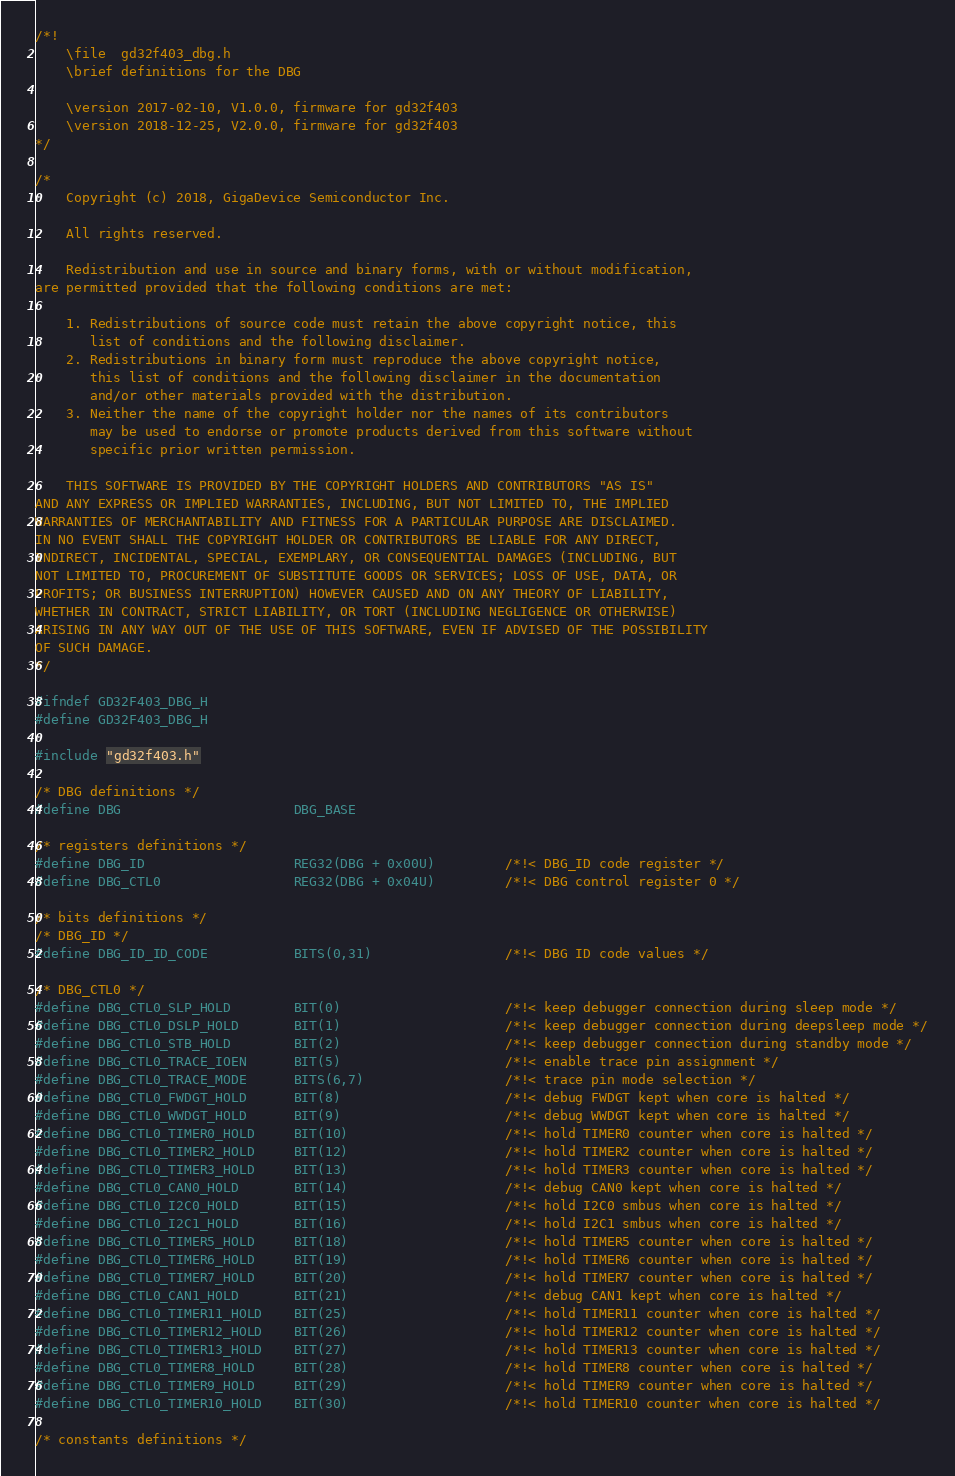<code> <loc_0><loc_0><loc_500><loc_500><_C_>/*!
    \file  gd32f403_dbg.h
    \brief definitions for the DBG

    \version 2017-02-10, V1.0.0, firmware for gd32f403
    \version 2018-12-25, V2.0.0, firmware for gd32f403
*/

/*
    Copyright (c) 2018, GigaDevice Semiconductor Inc.

    All rights reserved.

    Redistribution and use in source and binary forms, with or without modification, 
are permitted provided that the following conditions are met:

    1. Redistributions of source code must retain the above copyright notice, this 
       list of conditions and the following disclaimer.
    2. Redistributions in binary form must reproduce the above copyright notice, 
       this list of conditions and the following disclaimer in the documentation 
       and/or other materials provided with the distribution.
    3. Neither the name of the copyright holder nor the names of its contributors 
       may be used to endorse or promote products derived from this software without 
       specific prior written permission.

    THIS SOFTWARE IS PROVIDED BY THE COPYRIGHT HOLDERS AND CONTRIBUTORS "AS IS" 
AND ANY EXPRESS OR IMPLIED WARRANTIES, INCLUDING, BUT NOT LIMITED TO, THE IMPLIED 
WARRANTIES OF MERCHANTABILITY AND FITNESS FOR A PARTICULAR PURPOSE ARE DISCLAIMED. 
IN NO EVENT SHALL THE COPYRIGHT HOLDER OR CONTRIBUTORS BE LIABLE FOR ANY DIRECT, 
INDIRECT, INCIDENTAL, SPECIAL, EXEMPLARY, OR CONSEQUENTIAL DAMAGES (INCLUDING, BUT 
NOT LIMITED TO, PROCUREMENT OF SUBSTITUTE GOODS OR SERVICES; LOSS OF USE, DATA, OR 
PROFITS; OR BUSINESS INTERRUPTION) HOWEVER CAUSED AND ON ANY THEORY OF LIABILITY, 
WHETHER IN CONTRACT, STRICT LIABILITY, OR TORT (INCLUDING NEGLIGENCE OR OTHERWISE) 
ARISING IN ANY WAY OUT OF THE USE OF THIS SOFTWARE, EVEN IF ADVISED OF THE POSSIBILITY 
OF SUCH DAMAGE.
*/

#ifndef GD32F403_DBG_H
#define GD32F403_DBG_H

#include "gd32f403.h"

/* DBG definitions */
#define DBG                      DBG_BASE

/* registers definitions */
#define DBG_ID                   REG32(DBG + 0x00U)         /*!< DBG_ID code register */
#define DBG_CTL0                 REG32(DBG + 0x04U)         /*!< DBG control register 0 */

/* bits definitions */
/* DBG_ID */
#define DBG_ID_ID_CODE           BITS(0,31)                 /*!< DBG ID code values */

/* DBG_CTL0 */
#define DBG_CTL0_SLP_HOLD        BIT(0)                     /*!< keep debugger connection during sleep mode */
#define DBG_CTL0_DSLP_HOLD       BIT(1)                     /*!< keep debugger connection during deepsleep mode */
#define DBG_CTL0_STB_HOLD        BIT(2)                     /*!< keep debugger connection during standby mode */
#define DBG_CTL0_TRACE_IOEN      BIT(5)                     /*!< enable trace pin assignment */
#define DBG_CTL0_TRACE_MODE      BITS(6,7)                  /*!< trace pin mode selection */
#define DBG_CTL0_FWDGT_HOLD      BIT(8)                     /*!< debug FWDGT kept when core is halted */
#define DBG_CTL0_WWDGT_HOLD      BIT(9)                     /*!< debug WWDGT kept when core is halted */
#define DBG_CTL0_TIMER0_HOLD     BIT(10)                    /*!< hold TIMER0 counter when core is halted */
#define DBG_CTL0_TIMER2_HOLD     BIT(12)                    /*!< hold TIMER2 counter when core is halted */
#define DBG_CTL0_TIMER3_HOLD     BIT(13)                    /*!< hold TIMER3 counter when core is halted */
#define DBG_CTL0_CAN0_HOLD       BIT(14)                    /*!< debug CAN0 kept when core is halted */
#define DBG_CTL0_I2C0_HOLD       BIT(15)                    /*!< hold I2C0 smbus when core is halted */
#define DBG_CTL0_I2C1_HOLD       BIT(16)                    /*!< hold I2C1 smbus when core is halted */
#define DBG_CTL0_TIMER5_HOLD     BIT(18)                    /*!< hold TIMER5 counter when core is halted */
#define DBG_CTL0_TIMER6_HOLD     BIT(19)                    /*!< hold TIMER6 counter when core is halted */
#define DBG_CTL0_TIMER7_HOLD     BIT(20)                    /*!< hold TIMER7 counter when core is halted */
#define DBG_CTL0_CAN1_HOLD       BIT(21)                    /*!< debug CAN1 kept when core is halted */
#define DBG_CTL0_TIMER11_HOLD    BIT(25)                    /*!< hold TIMER11 counter when core is halted */
#define DBG_CTL0_TIMER12_HOLD    BIT(26)                    /*!< hold TIMER12 counter when core is halted */
#define DBG_CTL0_TIMER13_HOLD    BIT(27)                    /*!< hold TIMER13 counter when core is halted */
#define DBG_CTL0_TIMER8_HOLD     BIT(28)                    /*!< hold TIMER8 counter when core is halted */
#define DBG_CTL0_TIMER9_HOLD     BIT(29)                    /*!< hold TIMER9 counter when core is halted */
#define DBG_CTL0_TIMER10_HOLD    BIT(30)                    /*!< hold TIMER10 counter when core is halted */

/* constants definitions */</code> 